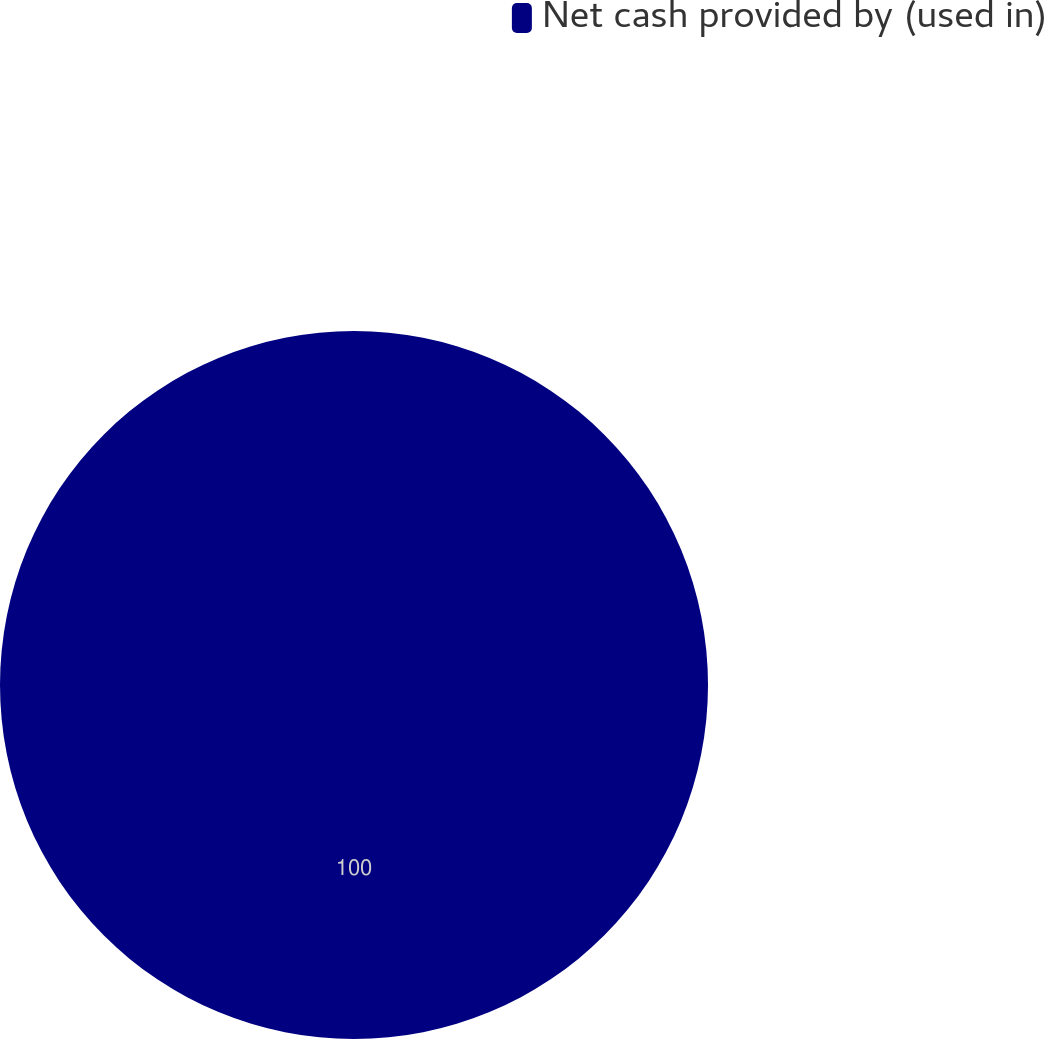<chart> <loc_0><loc_0><loc_500><loc_500><pie_chart><fcel>Net cash provided by (used in)<nl><fcel>100.0%<nl></chart> 